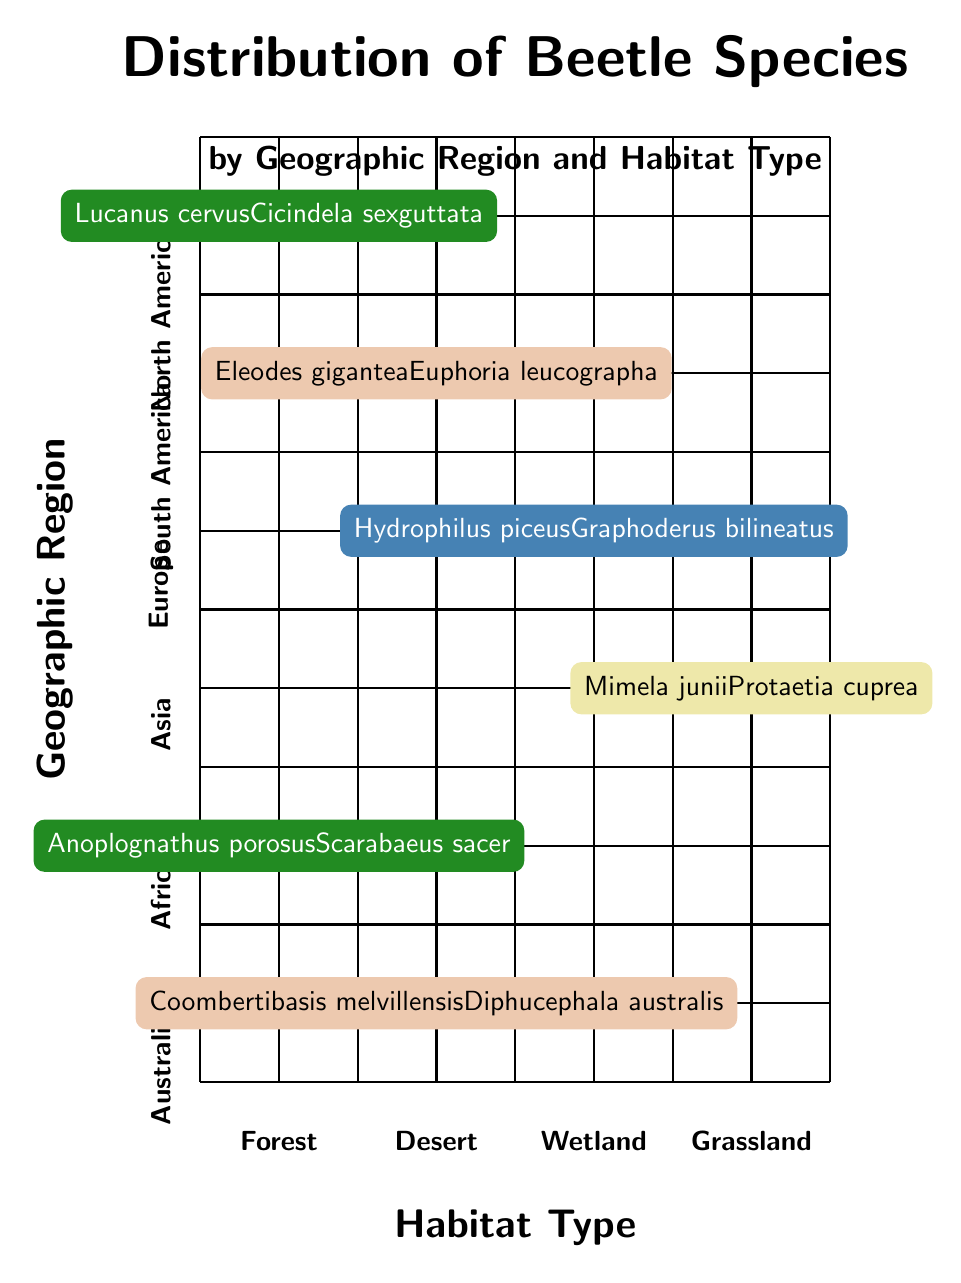What beetle species are found in North America Forest habitat? The diagram indicates that the software species in North America Forest habitat are "Lucanus cervus" and "Cicindela sexguttata".
Answer: Lucanus cervus, Cicindela sexguttata How many beetle species are listed for Desert habitats? The Desert habitat includes two regions on the chart: South America and Australia, each with two species listed, totaling four species.
Answer: 4 Which region is associated with the Wetland habitat? The diagram shows that the Wetland habitat corresponds to the Europe region.
Answer: Europe What is the habitat type in which "Anoplognathus porosus" is found? Through examining the chart, "Anoplognathus porosus" appears in the Forest habitat.
Answer: Forest Compare the number of species in Grassland vs. Wetland habitats. The Grassland habitat has two species listed (Asia), while Wetland (Europe) also has two species, making the counts equal.
Answer: Equal Which geographic region has the most diverse habitat types represented? Analyzing the diagram, it is evident that Africa has only one habitat type represented (Forest), indicating it does not have the most diversity. The region with the highest diversity would need to be assessed and shows fewer options than others.
Answer: Africa What are the two species found in the Desert of South America? The chart indicates that "Eleodes gigantea" and "Euphoria leucographa" are the two species found in the Desert of South America.
Answer: Eleodes gigantea, Euphoria leucographa Is there any habitat type that contains beetle species from two different regions? By inspecting the diagram, every habitat type only contains species from one region. Thus, no habitat shows representation from more than one region.
Answer: No 